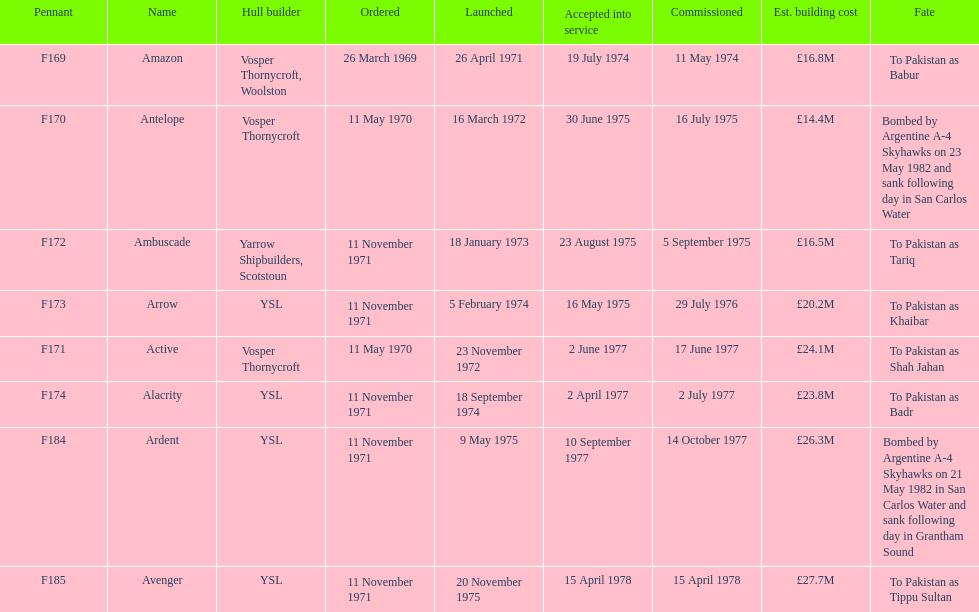I'm looking to parse the entire table for insights. Could you assist me with that? {'header': ['Pennant', 'Name', 'Hull builder', 'Ordered', 'Launched', 'Accepted into service', 'Commissioned', 'Est. building cost', 'Fate'], 'rows': [['F169', 'Amazon', 'Vosper Thornycroft, Woolston', '26 March 1969', '26 April 1971', '19 July 1974', '11 May 1974', '£16.8M', 'To Pakistan as Babur'], ['F170', 'Antelope', 'Vosper Thornycroft', '11 May 1970', '16 March 1972', '30 June 1975', '16 July 1975', '£14.4M', 'Bombed by Argentine A-4 Skyhawks on 23 May 1982 and sank following day in San Carlos Water'], ['F172', 'Ambuscade', 'Yarrow Shipbuilders, Scotstoun', '11 November 1971', '18 January 1973', '23 August 1975', '5 September 1975', '£16.5M', 'To Pakistan as Tariq'], ['F173', 'Arrow', 'YSL', '11 November 1971', '5 February 1974', '16 May 1975', '29 July 1976', '£20.2M', 'To Pakistan as Khaibar'], ['F171', 'Active', 'Vosper Thornycroft', '11 May 1970', '23 November 1972', '2 June 1977', '17 June 1977', '£24.1M', 'To Pakistan as Shah Jahan'], ['F174', 'Alacrity', 'YSL', '11 November 1971', '18 September 1974', '2 April 1977', '2 July 1977', '£23.8M', 'To Pakistan as Badr'], ['F184', 'Ardent', 'YSL', '11 November 1971', '9 May 1975', '10 September 1977', '14 October 1977', '£26.3M', 'Bombed by Argentine A-4 Skyhawks on 21 May 1982 in San Carlos Water and sank following day in Grantham Sound'], ['F185', 'Avenger', 'YSL', '11 November 1971', '20 November 1975', '15 April 1978', '15 April 1978', '£27.7M', 'To Pakistan as Tippu Sultan']]} How many boats costed less than £20m to build? 3. 